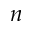<formula> <loc_0><loc_0><loc_500><loc_500>n</formula> 